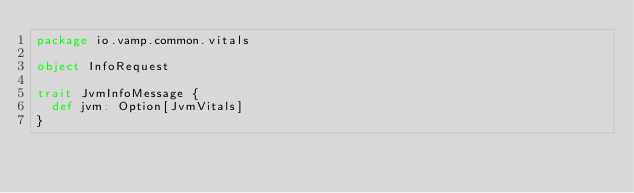<code> <loc_0><loc_0><loc_500><loc_500><_Scala_>package io.vamp.common.vitals

object InfoRequest

trait JvmInfoMessage {
  def jvm: Option[JvmVitals]
}</code> 